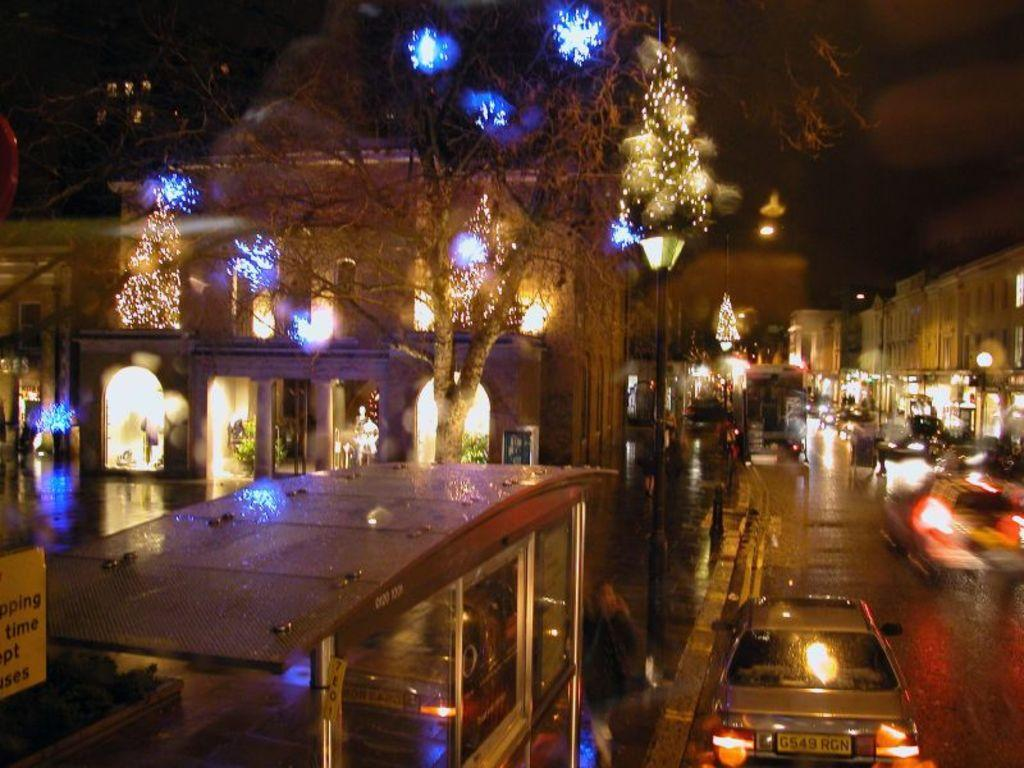What can be seen on the right side of the image? There is a road on the right side of the image. What is happening on the road? Vehicles are present on the road. What is located on the left side of the image? There are buildings, a board, a tree, and lights on the left side of the image. What is the condition of the sky in the image? The sky is visible in the image. Can you see any pigs on the island in the image? There is no island or pig present in the image. What type of dolls are sitting on the tree in the image? There are no dolls present in the image; it features a tree, buildings, a board, lights, and a road with vehicles. 